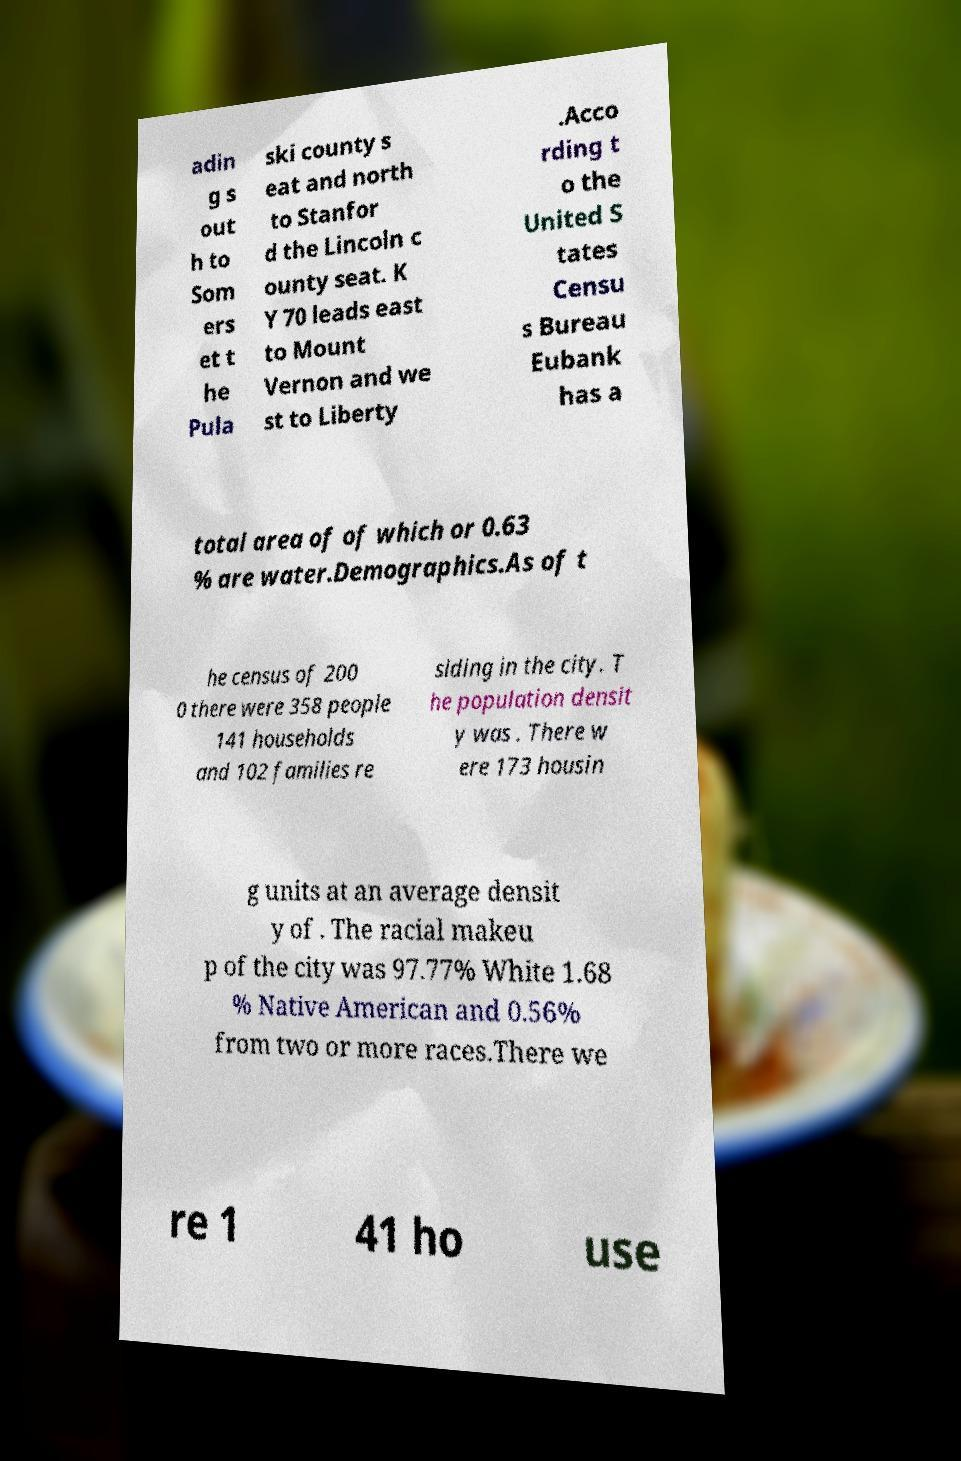Can you accurately transcribe the text from the provided image for me? adin g s out h to Som ers et t he Pula ski county s eat and north to Stanfor d the Lincoln c ounty seat. K Y 70 leads east to Mount Vernon and we st to Liberty .Acco rding t o the United S tates Censu s Bureau Eubank has a total area of of which or 0.63 % are water.Demographics.As of t he census of 200 0 there were 358 people 141 households and 102 families re siding in the city. T he population densit y was . There w ere 173 housin g units at an average densit y of . The racial makeu p of the city was 97.77% White 1.68 % Native American and 0.56% from two or more races.There we re 1 41 ho use 